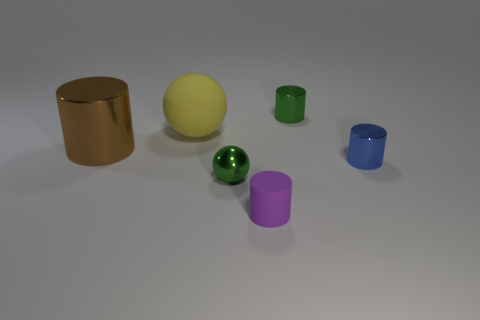Add 4 big brown objects. How many objects exist? 10 Subtract all cylinders. How many objects are left? 2 Subtract 0 red blocks. How many objects are left? 6 Subtract all large yellow balls. Subtract all big shiny cylinders. How many objects are left? 4 Add 3 tiny green cylinders. How many tiny green cylinders are left? 4 Add 4 green objects. How many green objects exist? 6 